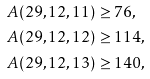<formula> <loc_0><loc_0><loc_500><loc_500>A ( 2 9 , 1 2 , 1 1 ) & \geq 7 6 , \\ A ( 2 9 , 1 2 , 1 2 ) & \geq 1 1 4 , \\ A ( 2 9 , 1 2 , 1 3 ) & \geq 1 4 0 ,</formula> 